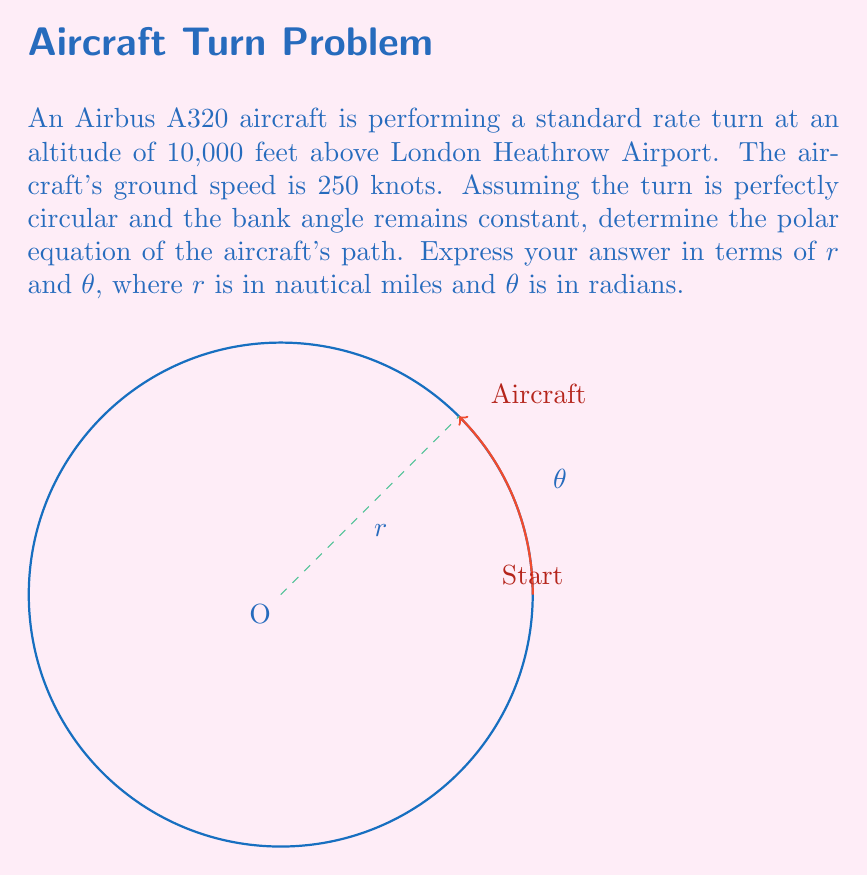Solve this math problem. Let's approach this step-by-step:

1) First, we need to calculate the radius of the turn. For a standard rate turn (3°/s), we can use the formula:

   $$R = \frac{V}{tan(\phi)}$$

   Where $R$ is the radius, $V$ is the ground speed, and $\phi$ is the bank angle.

2) We know that for a standard rate turn:

   $$tan(\phi) = \frac{V}{364.1}$$

3) Substituting this into our radius formula:

   $$R = \frac{V}{\frac{V}{364.1}} = 364.1 \text{ nautical miles}$$

4) Now, we have a circular path with a constant radius. In polar coordinates, this is represented by:

   $$r = R$$

5) Therefore, our polar equation is:

   $$r = 364.1$$

6) This equation describes a circle with a constant radius of 364.1 nautical miles, centered at the origin. The angle $\theta$ can vary from 0 to $2\pi$ to describe a full circle.

7) To express this in the standard form of a polar equation, we write:

   $$r = 364.1, \quad 0 \leq \theta < 2\pi$$
Answer: $r = 364.1, \quad 0 \leq \theta < 2\pi$ 